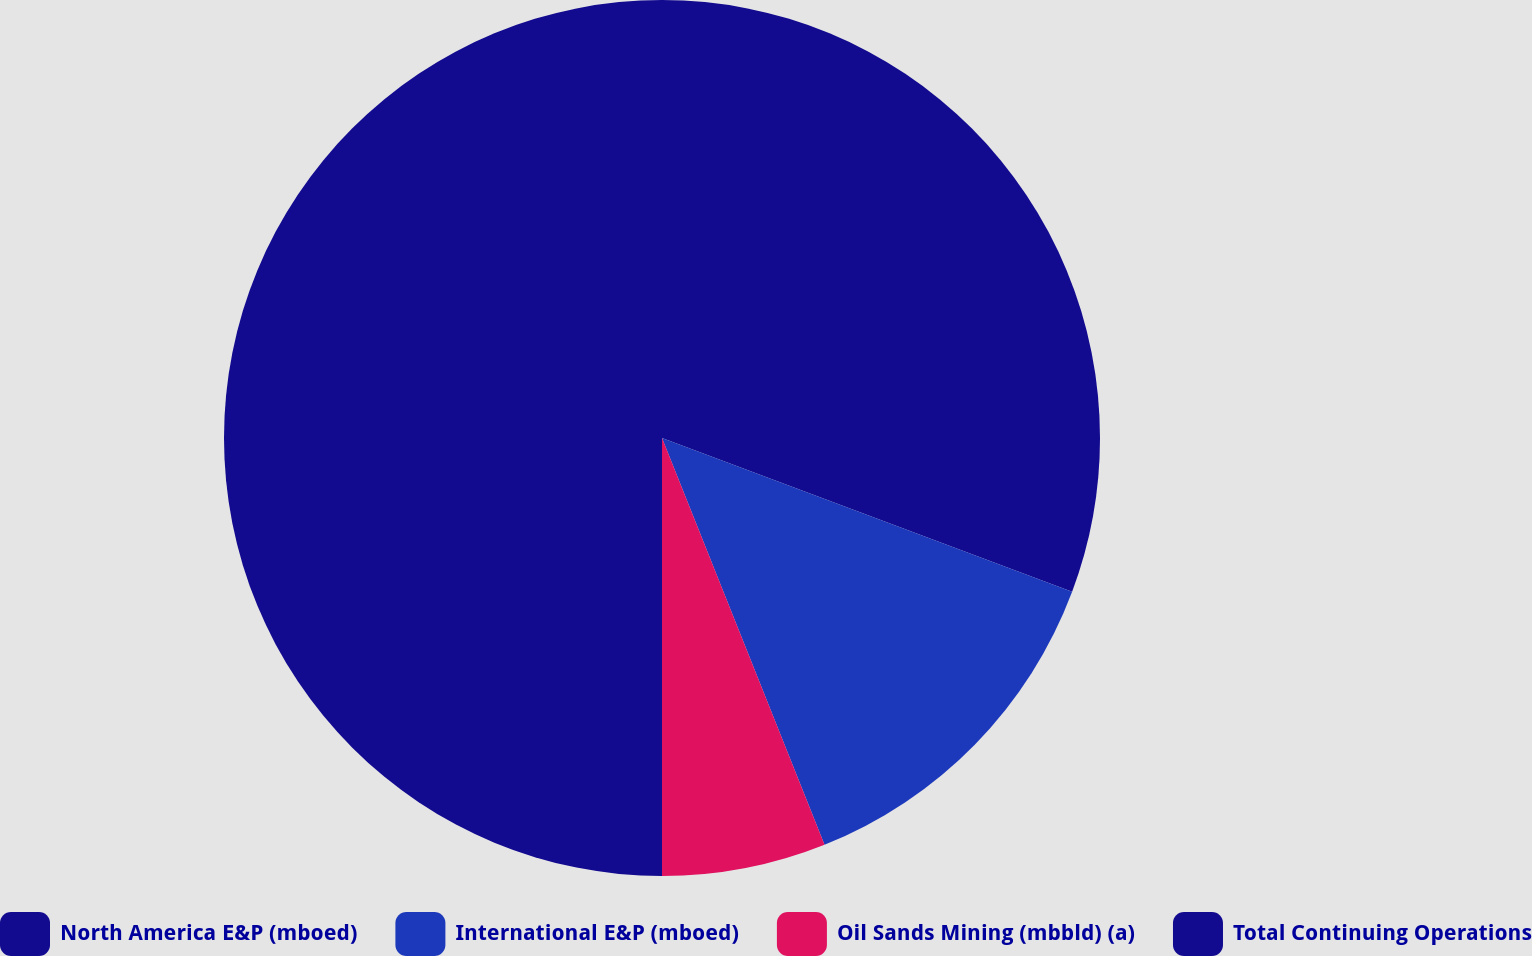<chart> <loc_0><loc_0><loc_500><loc_500><pie_chart><fcel>North America E&P (mboed)<fcel>International E&P (mboed)<fcel>Oil Sands Mining (mbbld) (a)<fcel>Total Continuing Operations<nl><fcel>30.71%<fcel>13.24%<fcel>6.05%<fcel>50.0%<nl></chart> 